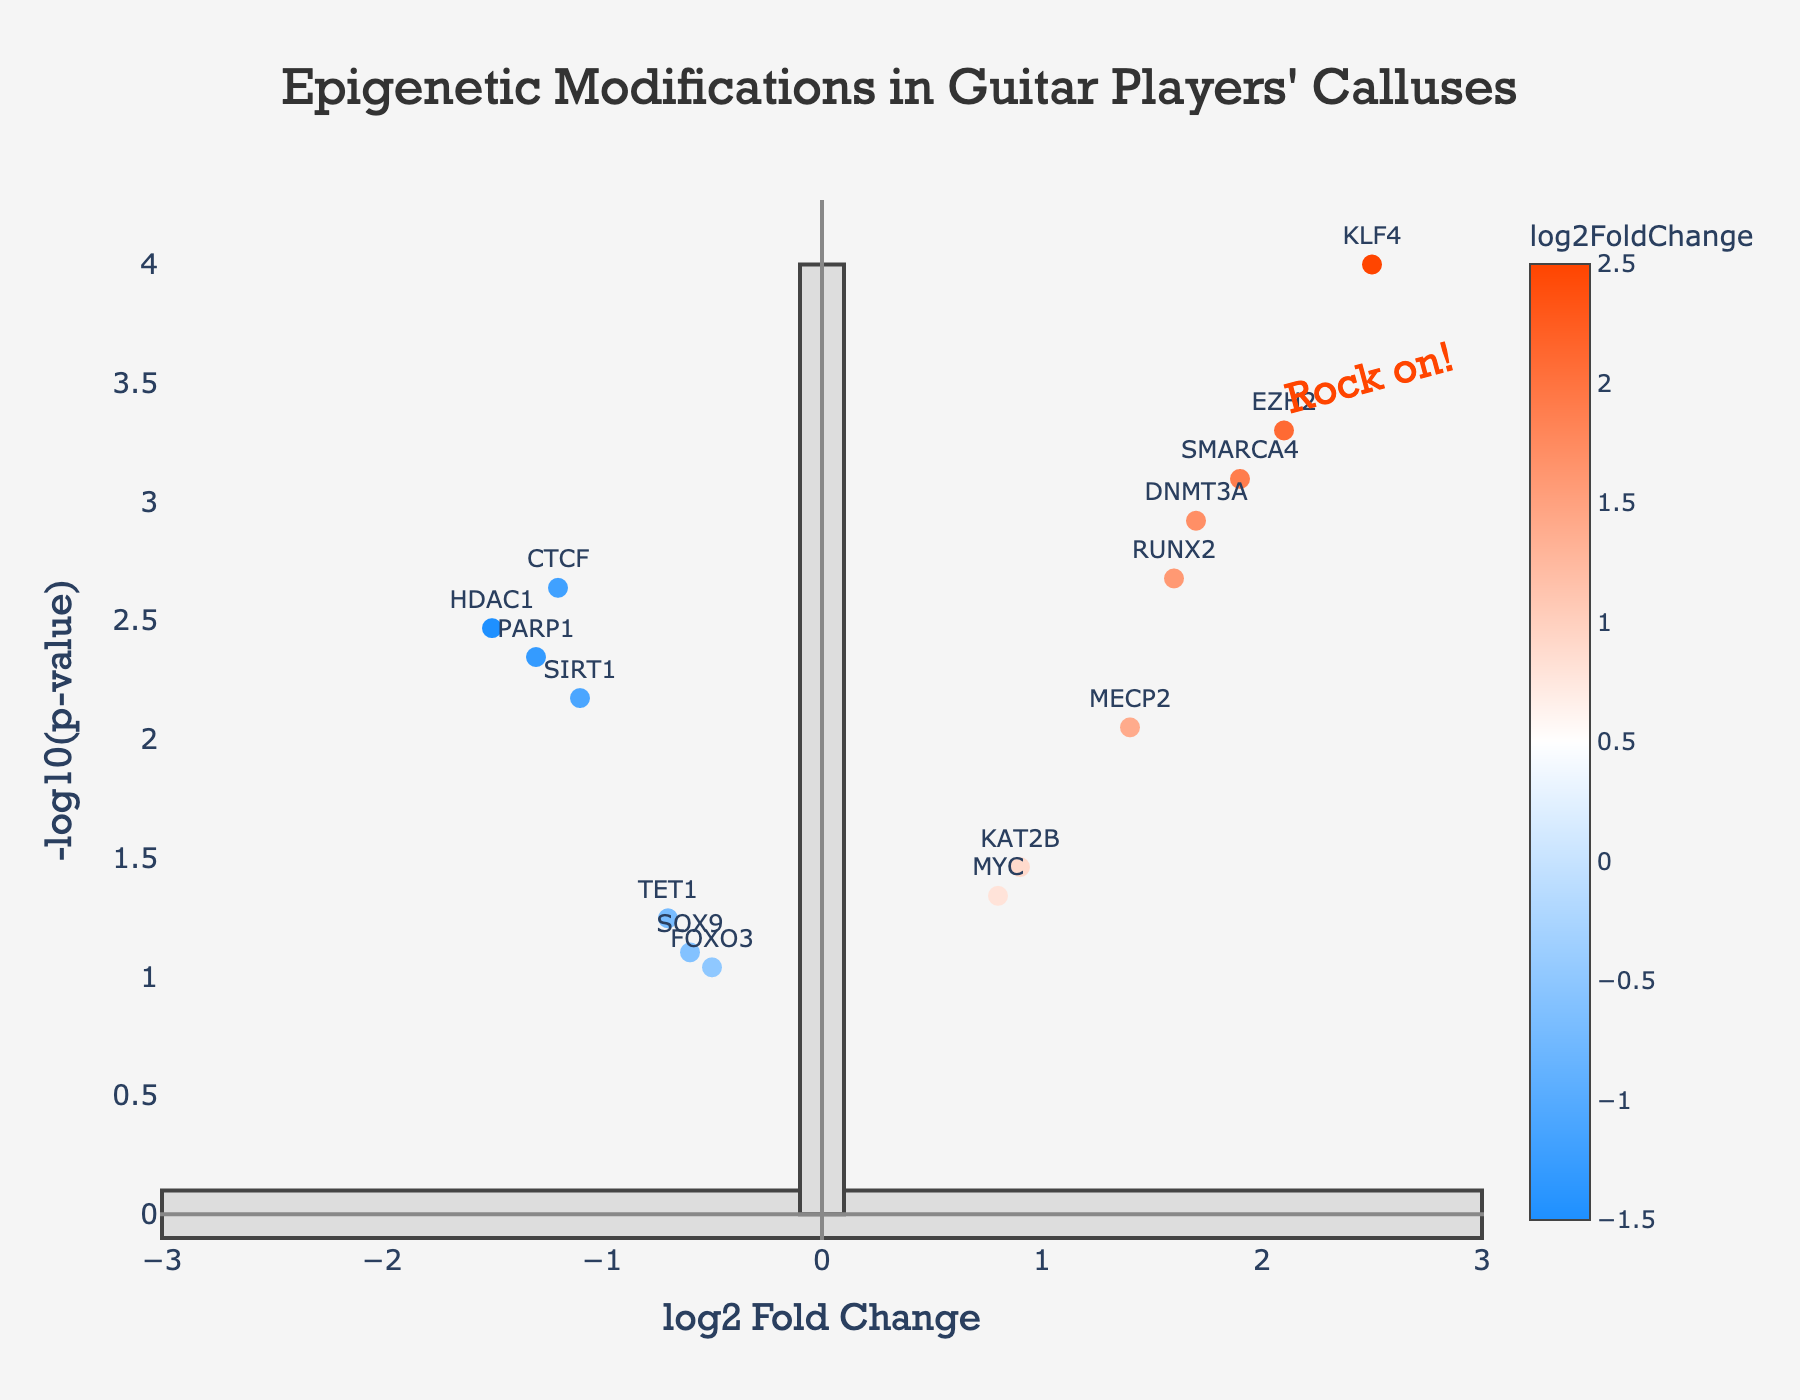What is the title of the plot? The title of the plot is shown at the top.
Answer: Epigenetic Modifications in Guitar Players' Calluses What are the axes labels of the plot? The x-axis label is at the bottom, and the y-axis label is on the left side.
Answer: The x-axis label is 'log2 Fold Change' and the y-axis label is '-log10(p-value)' How many genes have a log2FoldChange greater than 1.5? By looking at the x-values, select data points with log2FoldChange > 1.5.
Answer: 5 genes (KLF4, DNMT3A, EZH2, SMARCA4, RUNX2) What is the highest -log10(p-value) and which gene does it belong to? Identify the highest y-value and find the corresponding gene.
Answer: The highest -log10(p-value) is approximately 4 and it belongs to KLF4 Which gene has the most negative log2FoldChange? Identify the data point furthest to the left on the x-axis.
Answer: The gene with the most negative log2FoldChange is HDAC1 Are there any genes with a p-value greater than 0.05? Convert -log10(p-value) back to p-value and check the values.
Answer: Yes, SOX9, TET1, and FOXO3 have p-values greater than 0.05 Which gene is closest to the origin (0,0)? Find the data point that is closest to (0,0) in the plot.
Answer: The gene closest to the origin is FOXO3 How many genes exhibit a significant change in calluses with a p-value less than 0.01? Count the number of data points with -log10(p-value) > 2.
Answer: 9 genes Which genes have a log2FoldChange between -1 and 1? Identify data points where -1 <= log2FoldChange <= 1 on the x-axis.
Answer: MYC, SOX9, KAT2B, SIRT1, MECP2, and TET1 What can you say about the gene PARP1 based on its log2FoldChange and p-value? Check the plot for the coordinates of PARP1.
Answer: PARP1 has a negative log2FoldChange of -1.3 and a significant p-value below 0.01 